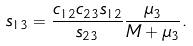Convert formula to latex. <formula><loc_0><loc_0><loc_500><loc_500>s _ { 1 3 } = \frac { c _ { 1 2 } c _ { 2 3 } s _ { 1 2 } } { s _ { 2 3 } } \frac { \mu _ { 3 } } { M + \mu _ { 3 } } .</formula> 